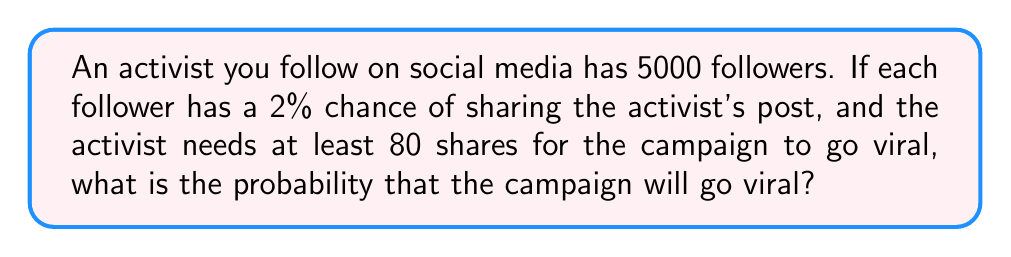Give your solution to this math problem. Let's approach this step-by-step:

1) This scenario follows a binomial distribution. We have:
   - $n = 5000$ (number of followers)
   - $p = 0.02$ (probability of each follower sharing)
   - We need to find $P(X \geq 80)$, where $X$ is the number of shares

2) The probability of the campaign going viral is the same as the probability of getting 80 or more shares.

3) It's easier to calculate the probability of not going viral and then subtract from 1:
   $P(\text{viral}) = 1 - P(X < 80) = 1 - P(X \leq 79)$

4) We can use the cumulative binomial probability function:

   $P(X \leq k) = \sum_{i=0}^k \binom{n}{i} p^i (1-p)^{n-i}$

5) However, calculating this directly would be time-consuming. Instead, we can use the normal approximation to the binomial distribution because $n$ is large and $np > 5$.

6) For a normal approximation:
   $\mu = np = 5000 \cdot 0.02 = 100$
   $\sigma = \sqrt{np(1-p)} = \sqrt{5000 \cdot 0.02 \cdot 0.98} = 9.849$

7) We need to find $P(X < 79.5)$ (using continuity correction):
   $z = \frac{79.5 - 100}{9.849} = -2.081$

8) Using a standard normal table or calculator, we find:
   $P(Z < -2.081) \approx 0.0187$

9) Therefore, $P(\text{viral}) = 1 - 0.0187 = 0.9813$
Answer: $0.9813$ or $98.13\%$ 